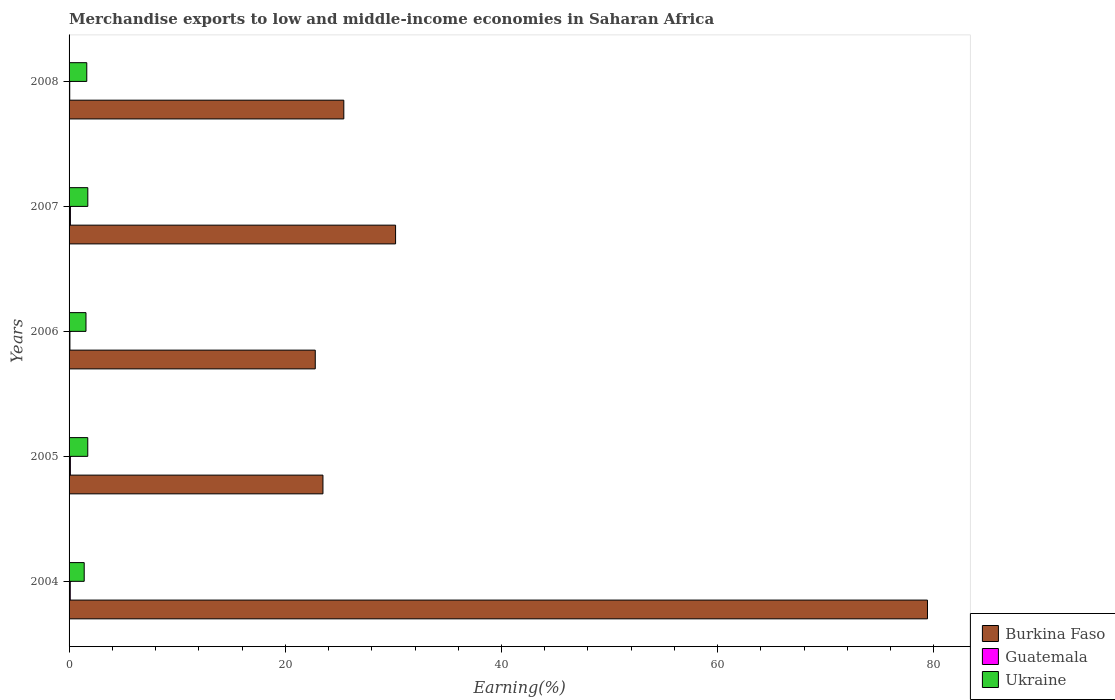How many different coloured bars are there?
Your answer should be compact. 3. How many groups of bars are there?
Give a very brief answer. 5. Are the number of bars per tick equal to the number of legend labels?
Offer a terse response. Yes. How many bars are there on the 4th tick from the bottom?
Provide a succinct answer. 3. What is the percentage of amount earned from merchandise exports in Ukraine in 2008?
Provide a succinct answer. 1.64. Across all years, what is the maximum percentage of amount earned from merchandise exports in Ukraine?
Provide a succinct answer. 1.73. Across all years, what is the minimum percentage of amount earned from merchandise exports in Guatemala?
Provide a succinct answer. 0.06. What is the total percentage of amount earned from merchandise exports in Guatemala in the graph?
Keep it short and to the point. 0.49. What is the difference between the percentage of amount earned from merchandise exports in Burkina Faso in 2005 and that in 2006?
Your answer should be compact. 0.71. What is the difference between the percentage of amount earned from merchandise exports in Guatemala in 2004 and the percentage of amount earned from merchandise exports in Burkina Faso in 2006?
Offer a terse response. -22.66. What is the average percentage of amount earned from merchandise exports in Guatemala per year?
Keep it short and to the point. 0.1. In the year 2008, what is the difference between the percentage of amount earned from merchandise exports in Guatemala and percentage of amount earned from merchandise exports in Ukraine?
Provide a succinct answer. -1.58. In how many years, is the percentage of amount earned from merchandise exports in Guatemala greater than 12 %?
Give a very brief answer. 0. What is the ratio of the percentage of amount earned from merchandise exports in Guatemala in 2004 to that in 2007?
Give a very brief answer. 0.88. Is the percentage of amount earned from merchandise exports in Burkina Faso in 2006 less than that in 2007?
Keep it short and to the point. Yes. What is the difference between the highest and the second highest percentage of amount earned from merchandise exports in Burkina Faso?
Ensure brevity in your answer.  49.2. What is the difference between the highest and the lowest percentage of amount earned from merchandise exports in Burkina Faso?
Your response must be concise. 56.63. In how many years, is the percentage of amount earned from merchandise exports in Guatemala greater than the average percentage of amount earned from merchandise exports in Guatemala taken over all years?
Ensure brevity in your answer.  3. What does the 3rd bar from the top in 2006 represents?
Provide a succinct answer. Burkina Faso. What does the 2nd bar from the bottom in 2006 represents?
Provide a short and direct response. Guatemala. Are all the bars in the graph horizontal?
Provide a succinct answer. Yes. Are the values on the major ticks of X-axis written in scientific E-notation?
Ensure brevity in your answer.  No. Does the graph contain any zero values?
Give a very brief answer. No. What is the title of the graph?
Give a very brief answer. Merchandise exports to low and middle-income economies in Saharan Africa. What is the label or title of the X-axis?
Offer a terse response. Earning(%). What is the Earning(%) of Burkina Faso in 2004?
Your answer should be very brief. 79.41. What is the Earning(%) of Guatemala in 2004?
Make the answer very short. 0.11. What is the Earning(%) of Ukraine in 2004?
Make the answer very short. 1.4. What is the Earning(%) in Burkina Faso in 2005?
Your answer should be very brief. 23.48. What is the Earning(%) of Guatemala in 2005?
Offer a terse response. 0.12. What is the Earning(%) in Ukraine in 2005?
Your answer should be compact. 1.73. What is the Earning(%) in Burkina Faso in 2006?
Provide a short and direct response. 22.77. What is the Earning(%) in Guatemala in 2006?
Make the answer very short. 0.08. What is the Earning(%) of Ukraine in 2006?
Your response must be concise. 1.56. What is the Earning(%) in Burkina Faso in 2007?
Keep it short and to the point. 30.2. What is the Earning(%) in Guatemala in 2007?
Your answer should be compact. 0.12. What is the Earning(%) of Ukraine in 2007?
Offer a very short reply. 1.73. What is the Earning(%) of Burkina Faso in 2008?
Give a very brief answer. 25.41. What is the Earning(%) in Guatemala in 2008?
Offer a terse response. 0.06. What is the Earning(%) in Ukraine in 2008?
Give a very brief answer. 1.64. Across all years, what is the maximum Earning(%) in Burkina Faso?
Keep it short and to the point. 79.41. Across all years, what is the maximum Earning(%) in Guatemala?
Keep it short and to the point. 0.12. Across all years, what is the maximum Earning(%) of Ukraine?
Offer a terse response. 1.73. Across all years, what is the minimum Earning(%) of Burkina Faso?
Provide a succinct answer. 22.77. Across all years, what is the minimum Earning(%) of Guatemala?
Provide a succinct answer. 0.06. Across all years, what is the minimum Earning(%) of Ukraine?
Ensure brevity in your answer.  1.4. What is the total Earning(%) of Burkina Faso in the graph?
Provide a succinct answer. 181.28. What is the total Earning(%) in Guatemala in the graph?
Your answer should be compact. 0.49. What is the total Earning(%) in Ukraine in the graph?
Make the answer very short. 8.07. What is the difference between the Earning(%) of Burkina Faso in 2004 and that in 2005?
Make the answer very short. 55.92. What is the difference between the Earning(%) in Guatemala in 2004 and that in 2005?
Provide a succinct answer. -0.01. What is the difference between the Earning(%) in Ukraine in 2004 and that in 2005?
Ensure brevity in your answer.  -0.33. What is the difference between the Earning(%) of Burkina Faso in 2004 and that in 2006?
Your answer should be very brief. 56.63. What is the difference between the Earning(%) in Guatemala in 2004 and that in 2006?
Provide a short and direct response. 0.03. What is the difference between the Earning(%) in Ukraine in 2004 and that in 2006?
Keep it short and to the point. -0.16. What is the difference between the Earning(%) in Burkina Faso in 2004 and that in 2007?
Provide a succinct answer. 49.2. What is the difference between the Earning(%) in Guatemala in 2004 and that in 2007?
Make the answer very short. -0.01. What is the difference between the Earning(%) in Ukraine in 2004 and that in 2007?
Keep it short and to the point. -0.33. What is the difference between the Earning(%) of Burkina Faso in 2004 and that in 2008?
Your answer should be very brief. 53.99. What is the difference between the Earning(%) of Guatemala in 2004 and that in 2008?
Provide a short and direct response. 0.05. What is the difference between the Earning(%) in Ukraine in 2004 and that in 2008?
Provide a succinct answer. -0.24. What is the difference between the Earning(%) of Burkina Faso in 2005 and that in 2006?
Offer a very short reply. 0.71. What is the difference between the Earning(%) in Guatemala in 2005 and that in 2006?
Offer a terse response. 0.04. What is the difference between the Earning(%) of Ukraine in 2005 and that in 2006?
Offer a terse response. 0.17. What is the difference between the Earning(%) in Burkina Faso in 2005 and that in 2007?
Keep it short and to the point. -6.72. What is the difference between the Earning(%) in Guatemala in 2005 and that in 2007?
Ensure brevity in your answer.  -0. What is the difference between the Earning(%) in Ukraine in 2005 and that in 2007?
Keep it short and to the point. -0. What is the difference between the Earning(%) of Burkina Faso in 2005 and that in 2008?
Give a very brief answer. -1.93. What is the difference between the Earning(%) of Guatemala in 2005 and that in 2008?
Give a very brief answer. 0.06. What is the difference between the Earning(%) of Ukraine in 2005 and that in 2008?
Provide a succinct answer. 0.09. What is the difference between the Earning(%) in Burkina Faso in 2006 and that in 2007?
Your answer should be very brief. -7.43. What is the difference between the Earning(%) in Guatemala in 2006 and that in 2007?
Your answer should be compact. -0.04. What is the difference between the Earning(%) in Ukraine in 2006 and that in 2007?
Give a very brief answer. -0.17. What is the difference between the Earning(%) of Burkina Faso in 2006 and that in 2008?
Offer a terse response. -2.64. What is the difference between the Earning(%) in Guatemala in 2006 and that in 2008?
Your response must be concise. 0.02. What is the difference between the Earning(%) in Ukraine in 2006 and that in 2008?
Offer a terse response. -0.07. What is the difference between the Earning(%) in Burkina Faso in 2007 and that in 2008?
Provide a short and direct response. 4.79. What is the difference between the Earning(%) in Guatemala in 2007 and that in 2008?
Keep it short and to the point. 0.06. What is the difference between the Earning(%) of Ukraine in 2007 and that in 2008?
Keep it short and to the point. 0.1. What is the difference between the Earning(%) of Burkina Faso in 2004 and the Earning(%) of Guatemala in 2005?
Your response must be concise. 79.28. What is the difference between the Earning(%) in Burkina Faso in 2004 and the Earning(%) in Ukraine in 2005?
Give a very brief answer. 77.68. What is the difference between the Earning(%) in Guatemala in 2004 and the Earning(%) in Ukraine in 2005?
Offer a very short reply. -1.62. What is the difference between the Earning(%) of Burkina Faso in 2004 and the Earning(%) of Guatemala in 2006?
Offer a terse response. 79.33. What is the difference between the Earning(%) of Burkina Faso in 2004 and the Earning(%) of Ukraine in 2006?
Give a very brief answer. 77.84. What is the difference between the Earning(%) in Guatemala in 2004 and the Earning(%) in Ukraine in 2006?
Your answer should be compact. -1.46. What is the difference between the Earning(%) in Burkina Faso in 2004 and the Earning(%) in Guatemala in 2007?
Ensure brevity in your answer.  79.28. What is the difference between the Earning(%) in Burkina Faso in 2004 and the Earning(%) in Ukraine in 2007?
Your answer should be very brief. 77.67. What is the difference between the Earning(%) of Guatemala in 2004 and the Earning(%) of Ukraine in 2007?
Provide a short and direct response. -1.62. What is the difference between the Earning(%) in Burkina Faso in 2004 and the Earning(%) in Guatemala in 2008?
Make the answer very short. 79.34. What is the difference between the Earning(%) in Burkina Faso in 2004 and the Earning(%) in Ukraine in 2008?
Keep it short and to the point. 77.77. What is the difference between the Earning(%) of Guatemala in 2004 and the Earning(%) of Ukraine in 2008?
Provide a short and direct response. -1.53. What is the difference between the Earning(%) in Burkina Faso in 2005 and the Earning(%) in Guatemala in 2006?
Provide a succinct answer. 23.41. What is the difference between the Earning(%) in Burkina Faso in 2005 and the Earning(%) in Ukraine in 2006?
Provide a short and direct response. 21.92. What is the difference between the Earning(%) of Guatemala in 2005 and the Earning(%) of Ukraine in 2006?
Your answer should be compact. -1.44. What is the difference between the Earning(%) in Burkina Faso in 2005 and the Earning(%) in Guatemala in 2007?
Your answer should be compact. 23.36. What is the difference between the Earning(%) of Burkina Faso in 2005 and the Earning(%) of Ukraine in 2007?
Your response must be concise. 21.75. What is the difference between the Earning(%) in Guatemala in 2005 and the Earning(%) in Ukraine in 2007?
Provide a short and direct response. -1.61. What is the difference between the Earning(%) of Burkina Faso in 2005 and the Earning(%) of Guatemala in 2008?
Ensure brevity in your answer.  23.42. What is the difference between the Earning(%) in Burkina Faso in 2005 and the Earning(%) in Ukraine in 2008?
Ensure brevity in your answer.  21.85. What is the difference between the Earning(%) in Guatemala in 2005 and the Earning(%) in Ukraine in 2008?
Your answer should be very brief. -1.52. What is the difference between the Earning(%) of Burkina Faso in 2006 and the Earning(%) of Guatemala in 2007?
Ensure brevity in your answer.  22.65. What is the difference between the Earning(%) of Burkina Faso in 2006 and the Earning(%) of Ukraine in 2007?
Keep it short and to the point. 21.04. What is the difference between the Earning(%) in Guatemala in 2006 and the Earning(%) in Ukraine in 2007?
Keep it short and to the point. -1.65. What is the difference between the Earning(%) in Burkina Faso in 2006 and the Earning(%) in Guatemala in 2008?
Provide a short and direct response. 22.71. What is the difference between the Earning(%) of Burkina Faso in 2006 and the Earning(%) of Ukraine in 2008?
Your answer should be very brief. 21.13. What is the difference between the Earning(%) of Guatemala in 2006 and the Earning(%) of Ukraine in 2008?
Keep it short and to the point. -1.56. What is the difference between the Earning(%) in Burkina Faso in 2007 and the Earning(%) in Guatemala in 2008?
Offer a very short reply. 30.14. What is the difference between the Earning(%) in Burkina Faso in 2007 and the Earning(%) in Ukraine in 2008?
Make the answer very short. 28.56. What is the difference between the Earning(%) in Guatemala in 2007 and the Earning(%) in Ukraine in 2008?
Ensure brevity in your answer.  -1.52. What is the average Earning(%) in Burkina Faso per year?
Your answer should be compact. 36.26. What is the average Earning(%) in Guatemala per year?
Give a very brief answer. 0.1. What is the average Earning(%) of Ukraine per year?
Offer a very short reply. 1.61. In the year 2004, what is the difference between the Earning(%) of Burkina Faso and Earning(%) of Guatemala?
Offer a very short reply. 79.3. In the year 2004, what is the difference between the Earning(%) in Burkina Faso and Earning(%) in Ukraine?
Offer a terse response. 78.01. In the year 2004, what is the difference between the Earning(%) of Guatemala and Earning(%) of Ukraine?
Your response must be concise. -1.29. In the year 2005, what is the difference between the Earning(%) in Burkina Faso and Earning(%) in Guatemala?
Provide a short and direct response. 23.36. In the year 2005, what is the difference between the Earning(%) in Burkina Faso and Earning(%) in Ukraine?
Provide a short and direct response. 21.75. In the year 2005, what is the difference between the Earning(%) in Guatemala and Earning(%) in Ukraine?
Keep it short and to the point. -1.61. In the year 2006, what is the difference between the Earning(%) in Burkina Faso and Earning(%) in Guatemala?
Your response must be concise. 22.69. In the year 2006, what is the difference between the Earning(%) in Burkina Faso and Earning(%) in Ukraine?
Give a very brief answer. 21.21. In the year 2006, what is the difference between the Earning(%) of Guatemala and Earning(%) of Ukraine?
Offer a very short reply. -1.49. In the year 2007, what is the difference between the Earning(%) in Burkina Faso and Earning(%) in Guatemala?
Your answer should be very brief. 30.08. In the year 2007, what is the difference between the Earning(%) of Burkina Faso and Earning(%) of Ukraine?
Keep it short and to the point. 28.47. In the year 2007, what is the difference between the Earning(%) in Guatemala and Earning(%) in Ukraine?
Provide a short and direct response. -1.61. In the year 2008, what is the difference between the Earning(%) of Burkina Faso and Earning(%) of Guatemala?
Your answer should be compact. 25.35. In the year 2008, what is the difference between the Earning(%) in Burkina Faso and Earning(%) in Ukraine?
Provide a short and direct response. 23.78. In the year 2008, what is the difference between the Earning(%) of Guatemala and Earning(%) of Ukraine?
Provide a succinct answer. -1.58. What is the ratio of the Earning(%) in Burkina Faso in 2004 to that in 2005?
Provide a succinct answer. 3.38. What is the ratio of the Earning(%) of Guatemala in 2004 to that in 2005?
Ensure brevity in your answer.  0.9. What is the ratio of the Earning(%) of Ukraine in 2004 to that in 2005?
Offer a very short reply. 0.81. What is the ratio of the Earning(%) of Burkina Faso in 2004 to that in 2006?
Your answer should be compact. 3.49. What is the ratio of the Earning(%) of Guatemala in 2004 to that in 2006?
Make the answer very short. 1.38. What is the ratio of the Earning(%) of Ukraine in 2004 to that in 2006?
Your answer should be compact. 0.9. What is the ratio of the Earning(%) of Burkina Faso in 2004 to that in 2007?
Your answer should be very brief. 2.63. What is the ratio of the Earning(%) in Guatemala in 2004 to that in 2007?
Your answer should be compact. 0.88. What is the ratio of the Earning(%) in Ukraine in 2004 to that in 2007?
Offer a very short reply. 0.81. What is the ratio of the Earning(%) of Burkina Faso in 2004 to that in 2008?
Offer a terse response. 3.12. What is the ratio of the Earning(%) of Guatemala in 2004 to that in 2008?
Provide a succinct answer. 1.78. What is the ratio of the Earning(%) of Ukraine in 2004 to that in 2008?
Make the answer very short. 0.85. What is the ratio of the Earning(%) of Burkina Faso in 2005 to that in 2006?
Make the answer very short. 1.03. What is the ratio of the Earning(%) in Guatemala in 2005 to that in 2006?
Your answer should be compact. 1.55. What is the ratio of the Earning(%) of Ukraine in 2005 to that in 2006?
Offer a terse response. 1.11. What is the ratio of the Earning(%) in Burkina Faso in 2005 to that in 2007?
Offer a very short reply. 0.78. What is the ratio of the Earning(%) in Guatemala in 2005 to that in 2007?
Your response must be concise. 0.98. What is the ratio of the Earning(%) in Ukraine in 2005 to that in 2007?
Make the answer very short. 1. What is the ratio of the Earning(%) in Burkina Faso in 2005 to that in 2008?
Keep it short and to the point. 0.92. What is the ratio of the Earning(%) in Guatemala in 2005 to that in 2008?
Ensure brevity in your answer.  1.99. What is the ratio of the Earning(%) in Ukraine in 2005 to that in 2008?
Offer a terse response. 1.06. What is the ratio of the Earning(%) in Burkina Faso in 2006 to that in 2007?
Offer a terse response. 0.75. What is the ratio of the Earning(%) in Guatemala in 2006 to that in 2007?
Your answer should be very brief. 0.64. What is the ratio of the Earning(%) in Ukraine in 2006 to that in 2007?
Provide a short and direct response. 0.9. What is the ratio of the Earning(%) of Burkina Faso in 2006 to that in 2008?
Provide a short and direct response. 0.9. What is the ratio of the Earning(%) of Guatemala in 2006 to that in 2008?
Provide a short and direct response. 1.29. What is the ratio of the Earning(%) in Ukraine in 2006 to that in 2008?
Offer a very short reply. 0.95. What is the ratio of the Earning(%) of Burkina Faso in 2007 to that in 2008?
Offer a terse response. 1.19. What is the ratio of the Earning(%) of Guatemala in 2007 to that in 2008?
Ensure brevity in your answer.  2.02. What is the ratio of the Earning(%) in Ukraine in 2007 to that in 2008?
Ensure brevity in your answer.  1.06. What is the difference between the highest and the second highest Earning(%) in Burkina Faso?
Provide a succinct answer. 49.2. What is the difference between the highest and the second highest Earning(%) in Guatemala?
Offer a terse response. 0. What is the difference between the highest and the second highest Earning(%) of Ukraine?
Give a very brief answer. 0. What is the difference between the highest and the lowest Earning(%) of Burkina Faso?
Make the answer very short. 56.63. What is the difference between the highest and the lowest Earning(%) in Guatemala?
Provide a succinct answer. 0.06. What is the difference between the highest and the lowest Earning(%) of Ukraine?
Keep it short and to the point. 0.33. 